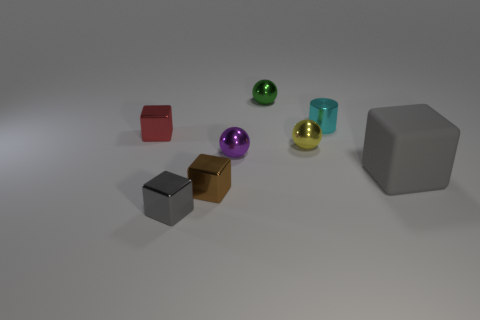What number of large things are either brown metal objects or metal spheres?
Provide a short and direct response. 0. What size is the cyan object?
Keep it short and to the point. Small. Are there any other things that are made of the same material as the purple sphere?
Your answer should be compact. Yes. What number of small yellow things are right of the gray matte thing?
Your response must be concise. 0. There is a brown shiny thing that is the same shape as the large rubber object; what size is it?
Provide a succinct answer. Small. How big is the metal sphere that is on the left side of the small yellow metal ball and in front of the cyan cylinder?
Make the answer very short. Small. There is a matte block; is it the same color as the tiny block behind the purple object?
Ensure brevity in your answer.  No. How many brown things are either tiny metal objects or small metal cylinders?
Offer a terse response. 1. What is the shape of the small gray object?
Make the answer very short. Cube. How many other objects are the same shape as the brown metallic thing?
Provide a short and direct response. 3. 